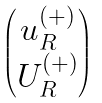Convert formula to latex. <formula><loc_0><loc_0><loc_500><loc_500>\begin{pmatrix} u ^ { ( + ) } _ { R } \\ U ^ { ( + ) } _ { R } \end{pmatrix}</formula> 